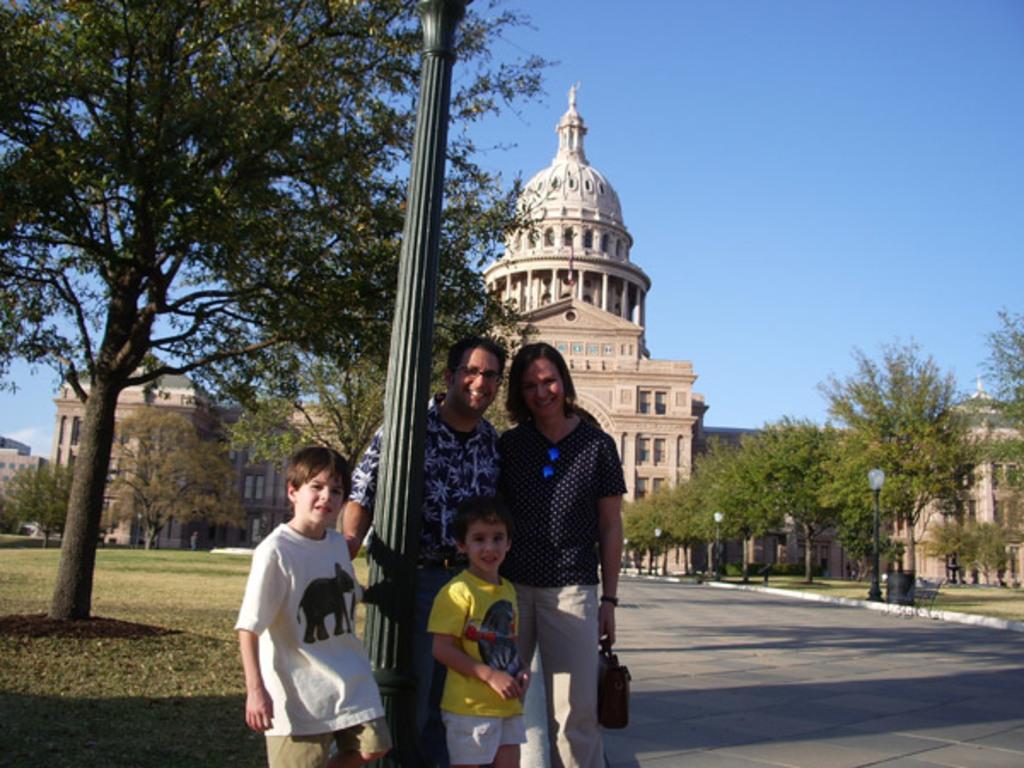Can you describe this image briefly? In this image there is a couple and two childrens are standing, in between them there is a pole. In the background there are trees, building and a sky. 